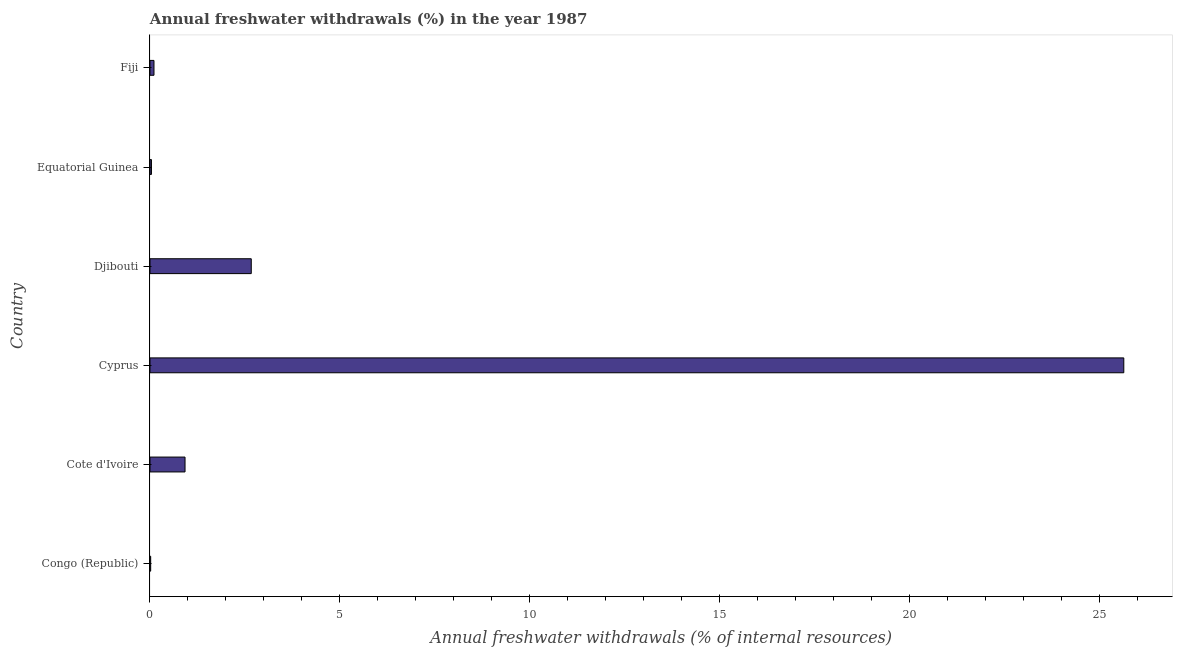What is the title of the graph?
Your answer should be compact. Annual freshwater withdrawals (%) in the year 1987. What is the label or title of the X-axis?
Provide a succinct answer. Annual freshwater withdrawals (% of internal resources). What is the label or title of the Y-axis?
Provide a short and direct response. Country. What is the annual freshwater withdrawals in Cyprus?
Make the answer very short. 25.64. Across all countries, what is the maximum annual freshwater withdrawals?
Your response must be concise. 25.64. Across all countries, what is the minimum annual freshwater withdrawals?
Keep it short and to the point. 0.02. In which country was the annual freshwater withdrawals maximum?
Your answer should be very brief. Cyprus. In which country was the annual freshwater withdrawals minimum?
Your answer should be very brief. Congo (Republic). What is the sum of the annual freshwater withdrawals?
Ensure brevity in your answer.  29.39. What is the difference between the annual freshwater withdrawals in Equatorial Guinea and Fiji?
Offer a very short reply. -0.07. What is the average annual freshwater withdrawals per country?
Your answer should be compact. 4.9. What is the median annual freshwater withdrawals?
Provide a succinct answer. 0.51. In how many countries, is the annual freshwater withdrawals greater than 10 %?
Provide a short and direct response. 1. Is the annual freshwater withdrawals in Congo (Republic) less than that in Djibouti?
Provide a succinct answer. Yes. Is the difference between the annual freshwater withdrawals in Equatorial Guinea and Fiji greater than the difference between any two countries?
Keep it short and to the point. No. What is the difference between the highest and the second highest annual freshwater withdrawals?
Provide a short and direct response. 22.97. What is the difference between the highest and the lowest annual freshwater withdrawals?
Offer a terse response. 25.62. In how many countries, is the annual freshwater withdrawals greater than the average annual freshwater withdrawals taken over all countries?
Provide a succinct answer. 1. How many bars are there?
Offer a very short reply. 6. Are all the bars in the graph horizontal?
Ensure brevity in your answer.  Yes. Are the values on the major ticks of X-axis written in scientific E-notation?
Ensure brevity in your answer.  No. What is the Annual freshwater withdrawals (% of internal resources) of Congo (Republic)?
Your answer should be compact. 0.02. What is the Annual freshwater withdrawals (% of internal resources) of Cote d'Ivoire?
Your response must be concise. 0.92. What is the Annual freshwater withdrawals (% of internal resources) in Cyprus?
Offer a terse response. 25.64. What is the Annual freshwater withdrawals (% of internal resources) in Djibouti?
Provide a succinct answer. 2.67. What is the Annual freshwater withdrawals (% of internal resources) of Equatorial Guinea?
Give a very brief answer. 0.04. What is the Annual freshwater withdrawals (% of internal resources) of Fiji?
Provide a short and direct response. 0.11. What is the difference between the Annual freshwater withdrawals (% of internal resources) in Congo (Republic) and Cote d'Ivoire?
Your answer should be very brief. -0.9. What is the difference between the Annual freshwater withdrawals (% of internal resources) in Congo (Republic) and Cyprus?
Offer a terse response. -25.62. What is the difference between the Annual freshwater withdrawals (% of internal resources) in Congo (Republic) and Djibouti?
Make the answer very short. -2.65. What is the difference between the Annual freshwater withdrawals (% of internal resources) in Congo (Republic) and Equatorial Guinea?
Keep it short and to the point. -0.02. What is the difference between the Annual freshwater withdrawals (% of internal resources) in Congo (Republic) and Fiji?
Offer a very short reply. -0.09. What is the difference between the Annual freshwater withdrawals (% of internal resources) in Cote d'Ivoire and Cyprus?
Offer a very short reply. -24.72. What is the difference between the Annual freshwater withdrawals (% of internal resources) in Cote d'Ivoire and Djibouti?
Provide a succinct answer. -1.74. What is the difference between the Annual freshwater withdrawals (% of internal resources) in Cote d'Ivoire and Equatorial Guinea?
Offer a very short reply. 0.88. What is the difference between the Annual freshwater withdrawals (% of internal resources) in Cote d'Ivoire and Fiji?
Offer a very short reply. 0.82. What is the difference between the Annual freshwater withdrawals (% of internal resources) in Cyprus and Djibouti?
Provide a short and direct response. 22.97. What is the difference between the Annual freshwater withdrawals (% of internal resources) in Cyprus and Equatorial Guinea?
Give a very brief answer. 25.6. What is the difference between the Annual freshwater withdrawals (% of internal resources) in Cyprus and Fiji?
Your response must be concise. 25.54. What is the difference between the Annual freshwater withdrawals (% of internal resources) in Djibouti and Equatorial Guinea?
Offer a very short reply. 2.63. What is the difference between the Annual freshwater withdrawals (% of internal resources) in Djibouti and Fiji?
Offer a very short reply. 2.56. What is the difference between the Annual freshwater withdrawals (% of internal resources) in Equatorial Guinea and Fiji?
Give a very brief answer. -0.07. What is the ratio of the Annual freshwater withdrawals (% of internal resources) in Congo (Republic) to that in Cyprus?
Your answer should be compact. 0. What is the ratio of the Annual freshwater withdrawals (% of internal resources) in Congo (Republic) to that in Djibouti?
Your answer should be very brief. 0.01. What is the ratio of the Annual freshwater withdrawals (% of internal resources) in Congo (Republic) to that in Equatorial Guinea?
Your answer should be compact. 0.47. What is the ratio of the Annual freshwater withdrawals (% of internal resources) in Congo (Republic) to that in Fiji?
Provide a succinct answer. 0.17. What is the ratio of the Annual freshwater withdrawals (% of internal resources) in Cote d'Ivoire to that in Cyprus?
Make the answer very short. 0.04. What is the ratio of the Annual freshwater withdrawals (% of internal resources) in Cote d'Ivoire to that in Djibouti?
Your answer should be very brief. 0.35. What is the ratio of the Annual freshwater withdrawals (% of internal resources) in Cote d'Ivoire to that in Equatorial Guinea?
Your response must be concise. 23.99. What is the ratio of the Annual freshwater withdrawals (% of internal resources) in Cote d'Ivoire to that in Fiji?
Keep it short and to the point. 8.78. What is the ratio of the Annual freshwater withdrawals (% of internal resources) in Cyprus to that in Djibouti?
Ensure brevity in your answer.  9.62. What is the ratio of the Annual freshwater withdrawals (% of internal resources) in Cyprus to that in Equatorial Guinea?
Keep it short and to the point. 666.67. What is the ratio of the Annual freshwater withdrawals (% of internal resources) in Cyprus to that in Fiji?
Your answer should be very brief. 244.02. What is the ratio of the Annual freshwater withdrawals (% of internal resources) in Djibouti to that in Equatorial Guinea?
Your answer should be very brief. 69.33. What is the ratio of the Annual freshwater withdrawals (% of internal resources) in Djibouti to that in Fiji?
Offer a terse response. 25.38. What is the ratio of the Annual freshwater withdrawals (% of internal resources) in Equatorial Guinea to that in Fiji?
Your answer should be compact. 0.37. 